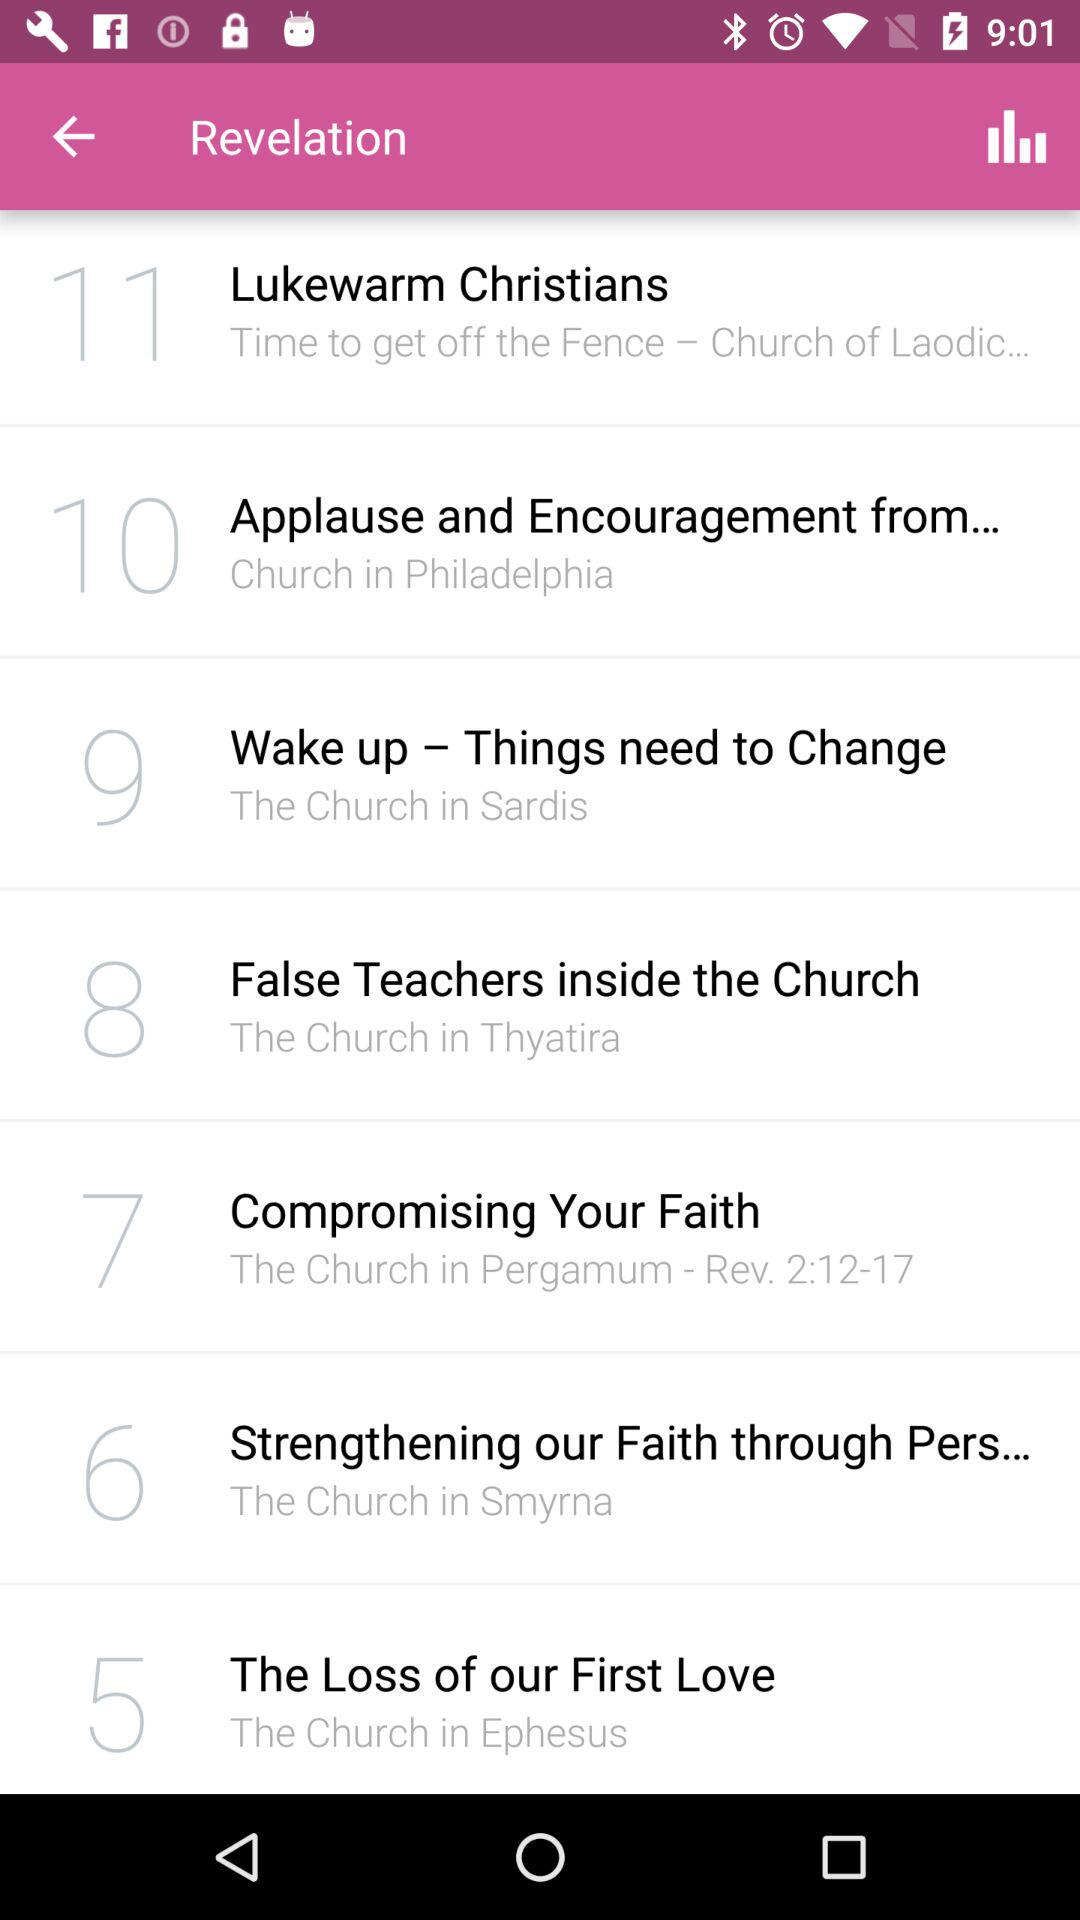What has the serial number 10? The serial number 10 is for "Applause and Encouragement from...". 